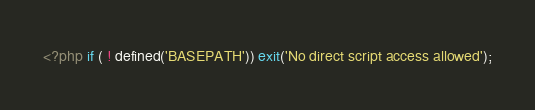Convert code to text. <code><loc_0><loc_0><loc_500><loc_500><_PHP_><?php if ( ! defined('BASEPATH')) exit('No direct script access allowed');</code> 